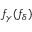Convert formula to latex. <formula><loc_0><loc_0><loc_500><loc_500>f _ { \gamma } ( f _ { \delta } )</formula> 